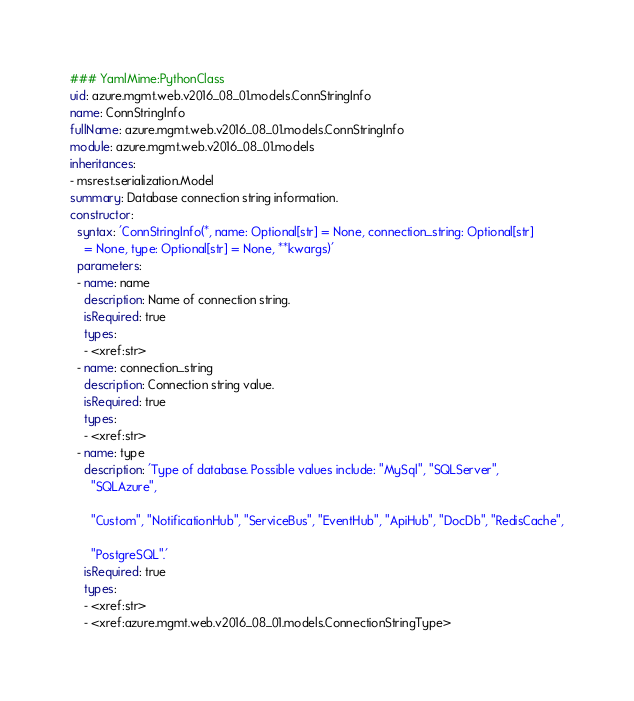Convert code to text. <code><loc_0><loc_0><loc_500><loc_500><_YAML_>### YamlMime:PythonClass
uid: azure.mgmt.web.v2016_08_01.models.ConnStringInfo
name: ConnStringInfo
fullName: azure.mgmt.web.v2016_08_01.models.ConnStringInfo
module: azure.mgmt.web.v2016_08_01.models
inheritances:
- msrest.serialization.Model
summary: Database connection string information.
constructor:
  syntax: 'ConnStringInfo(*, name: Optional[str] = None, connection_string: Optional[str]
    = None, type: Optional[str] = None, **kwargs)'
  parameters:
  - name: name
    description: Name of connection string.
    isRequired: true
    types:
    - <xref:str>
  - name: connection_string
    description: Connection string value.
    isRequired: true
    types:
    - <xref:str>
  - name: type
    description: 'Type of database. Possible values include: "MySql", "SQLServer",
      "SQLAzure",

      "Custom", "NotificationHub", "ServiceBus", "EventHub", "ApiHub", "DocDb", "RedisCache",

      "PostgreSQL".'
    isRequired: true
    types:
    - <xref:str>
    - <xref:azure.mgmt.web.v2016_08_01.models.ConnectionStringType>
</code> 